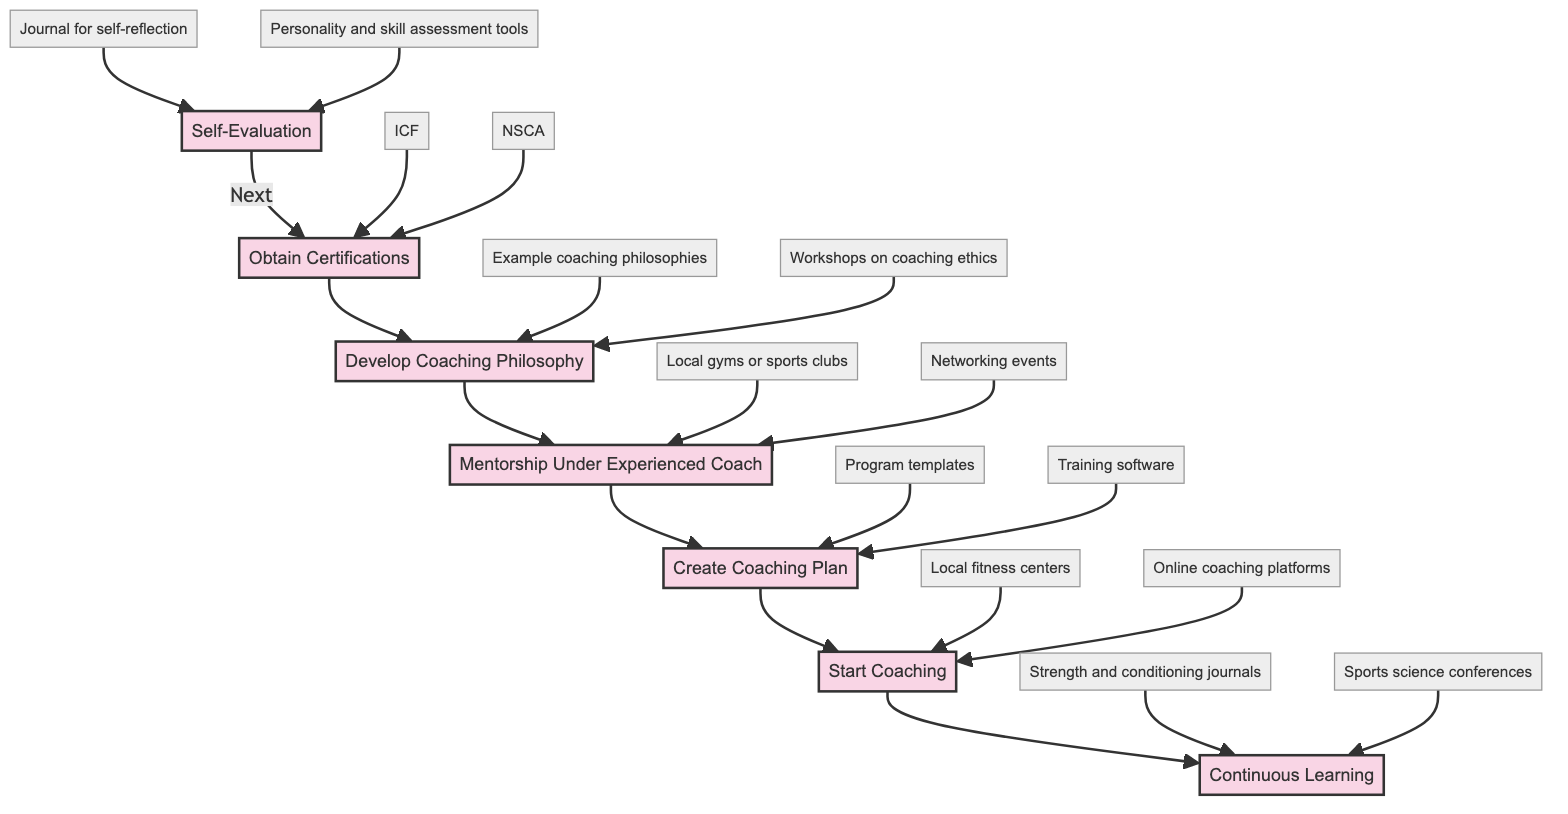What is the first step in the clinical pathway? The first step in the clinical pathway is indicated by the starting node, which is "Self-Evaluation." This node is the entry point before other steps, confirming its position as the initial action to take.
Answer: Self-Evaluation How many steps are there in total? Counting all the steps listed in the diagram, we see seven distinct processes arranged sequentially, verifying the total number of steps.
Answer: Seven Which step follows "Obtain Certifications"? The step directly succeeding "Obtain Certifications" in the flowchart is connected by an arrow, indicating that "Develop Coaching Philosophy" comes next after completing certifications.
Answer: Develop Coaching Philosophy What resources are associated with "Start Coaching"? The resources linked to "Start Coaching" can be identified by looking at the resources that branch from this node, where "Local fitness centers" and "Online coaching platforms" are clearly stated.
Answer: Local fitness centers, Online coaching platforms Which step involves working under an experienced coach? By locating the step that describes gaining practical insights from others, we find that "Mentorship Under Experienced Coach" explicitly states this activity, directly indicating the involvement with an experienced professional.
Answer: Mentorship Under Experienced Coach What is the main focus of the "Continuous Learning" step? The "Continuous Learning" step emphasizes the ongoing process of updating knowledge and skills, as described in its node, which highlights the necessity of regular education through various courses and conferences.
Answer: Regular education How many resources are listed for the "Develop Coaching Philosophy"? Looking at the resources branching from "Develop Coaching Philosophy," we identify two resources explicitly named as "Example coaching philosophies" and "Workshops on coaching ethics," which confirms the count.
Answer: Two What is listed as a resource for "Self-Evaluation"? Examining the resources stemming from the "Self-Evaluation" step, we see two resources, notably "Journal for self-reflection" and "Personality and skill assessment tools," which directly support the self-evaluation process.
Answer: Journal for self-reflection, Personality and skill assessment tools Which step comes after "Create Coaching Plan"? The flowchart indicates progression from the node of "Create Coaching Plan" to the subsequent node of "Start Coaching," which logically follows as the next action to take.
Answer: Start Coaching 